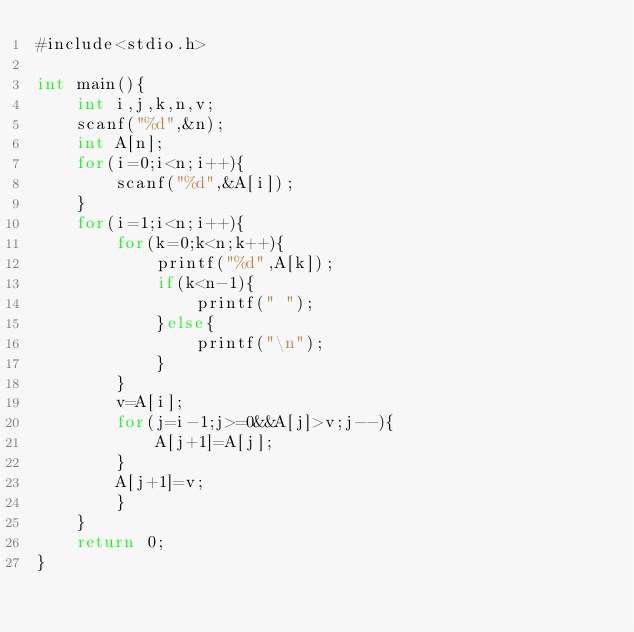<code> <loc_0><loc_0><loc_500><loc_500><_C#_>#include<stdio.h>

int main(){
    int i,j,k,n,v;
    scanf("%d",&n);
    int A[n];
    for(i=0;i<n;i++){
        scanf("%d",&A[i]);
    }
    for(i=1;i<n;i++){
        for(k=0;k<n;k++){
            printf("%d",A[k]);
            if(k<n-1){
                printf(" ");
            }else{
                printf("\n");
            }
        }
        v=A[i];
        for(j=i-1;j>=0&&A[j]>v;j--){
            A[j+1]=A[j];
        }
        A[j+1]=v;
        }
    }
    return 0;
}
</code> 